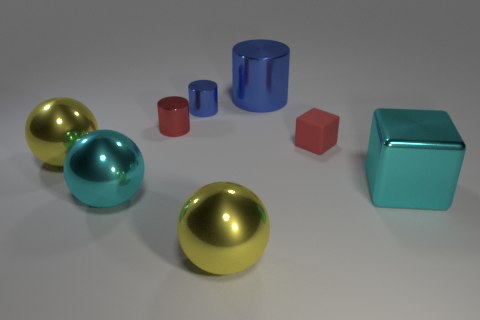What is the color of the tiny object to the right of the big blue cylinder?
Your response must be concise. Red. There is a big cyan object that is in front of the large block; is there a big shiny cylinder on the right side of it?
Give a very brief answer. Yes. There is a small rubber object; does it have the same color as the small metal cylinder that is left of the tiny blue object?
Your answer should be compact. Yes. Is there a red ball made of the same material as the large cylinder?
Give a very brief answer. No. What number of small objects are there?
Your response must be concise. 3. The big thing to the right of the tiny red block right of the large blue object is made of what material?
Offer a terse response. Metal. What color is the big cylinder that is made of the same material as the small blue cylinder?
Give a very brief answer. Blue. There is a tiny metallic object that is the same color as the tiny matte object; what shape is it?
Offer a very short reply. Cylinder. There is a red object behind the rubber thing; does it have the same size as the matte object left of the shiny block?
Keep it short and to the point. Yes. How many spheres are either cyan objects or yellow metal objects?
Your answer should be compact. 3. 